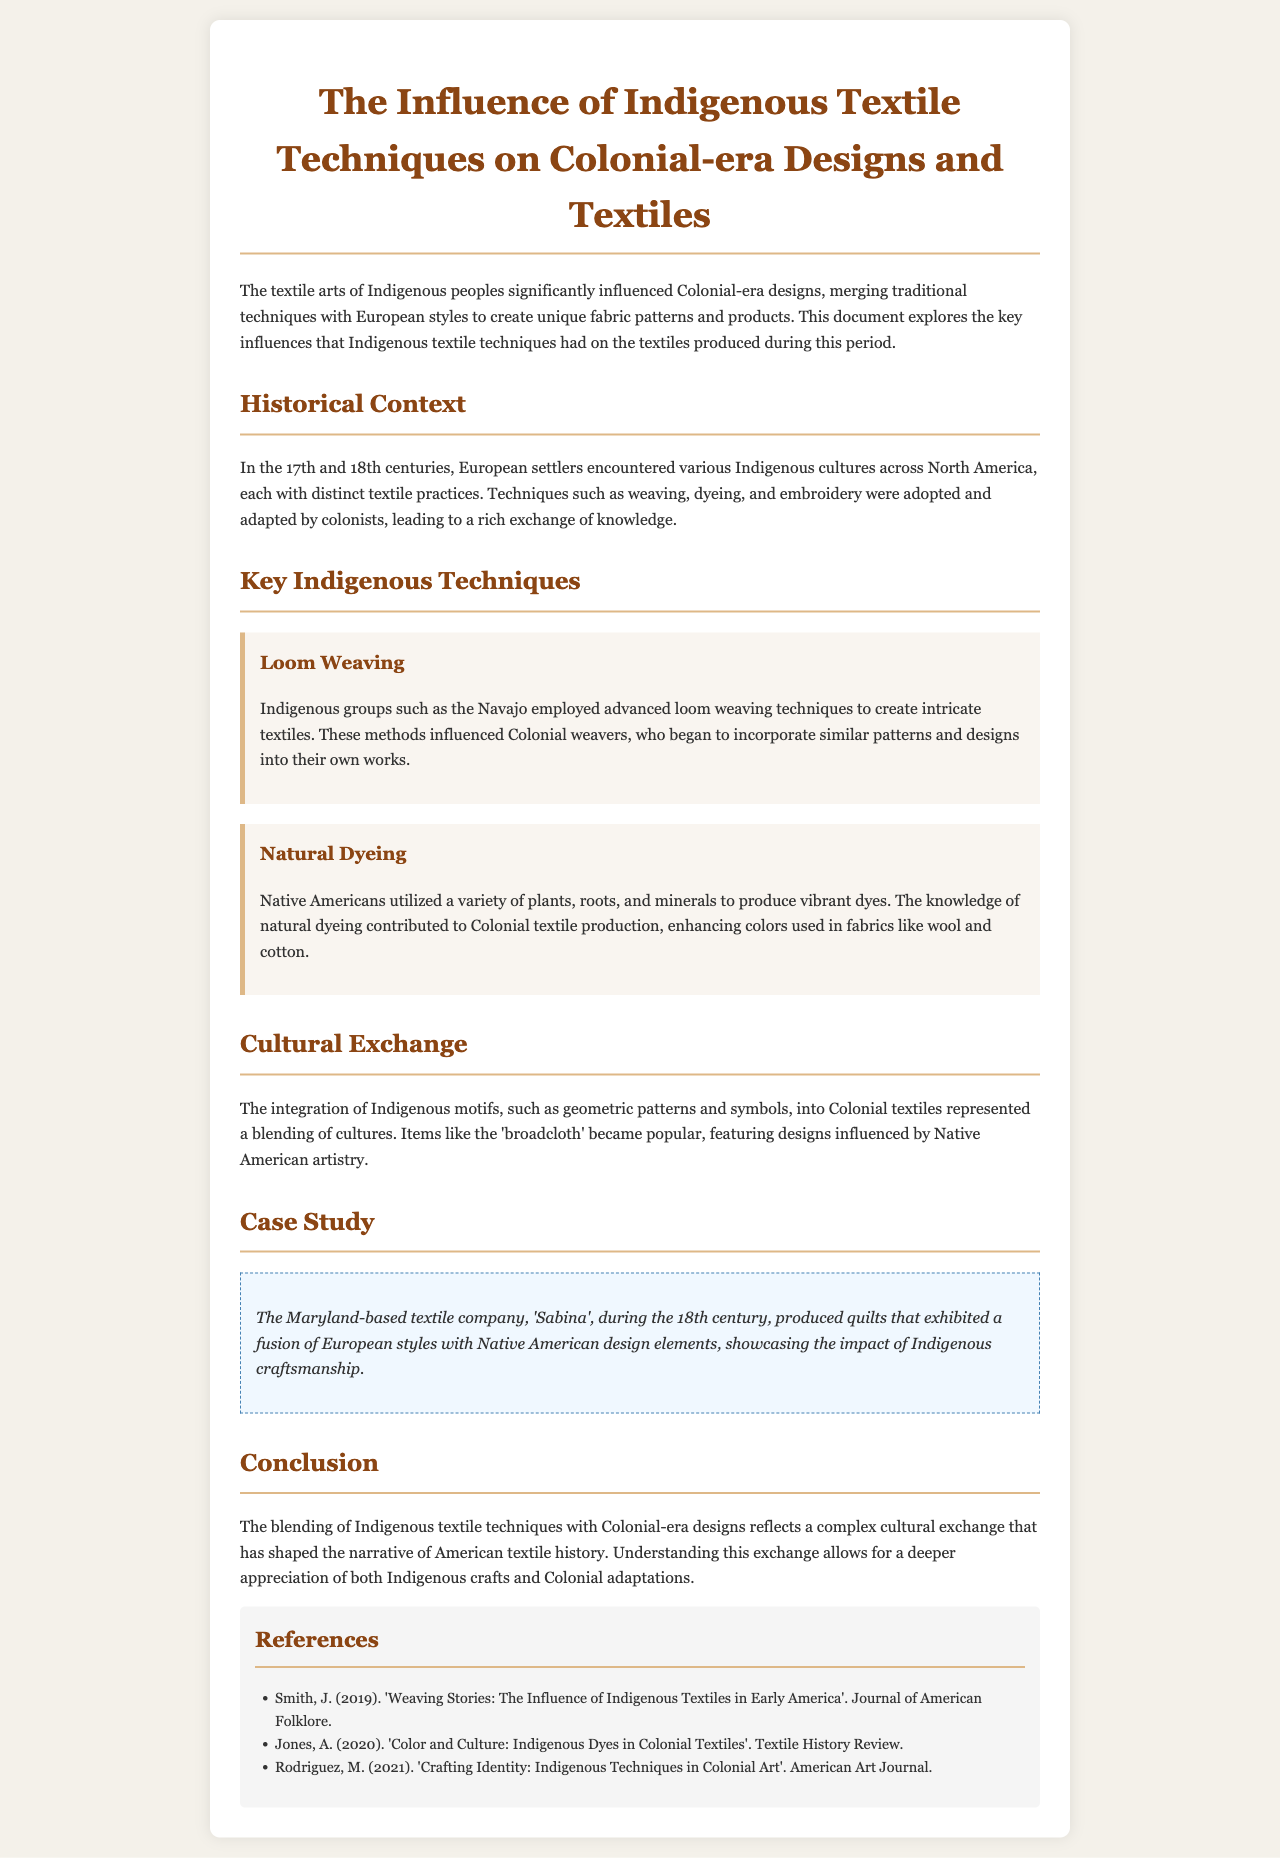What is the title of the document? The title is found at the top of the report, summarizing its main focus.
Answer: The Influence of Indigenous Textile Techniques on Colonial-era Designs and Textiles Which Indigenous group is mentioned for advanced loom weaving techniques? The document explicitly states which Indigenous group employed these techniques within the section discussing key techniques.
Answer: Navajo What century did the Maryland-based textile company 'Sabina' operate in? The case study section specifies the time period during which the company produced its textiles.
Answer: 18th century What type of dyeing did Native Americans use that influenced Colonial textile production? The document identifies the type of dyeing as it relates to vibrant colors in textiles.
Answer: Natural dyeing What did the integration of Indigenous motifs into Colonial textiles represent? The document summarizes the cultural implications of this integration in the cultural exchange section.
Answer: A blending of cultures How did Indigenous techniques influence Colonial weavers? The document mentions the specific techniques and their impact on colonists' practices.
Answer: Incorporate similar patterns and designs What was a popular item featuring designs influenced by Native American artistry? The document refers to a specific product to illustrate the integration of Indigenous designs.
Answer: Broadcloth What are the colors used in fabrics enhanced by Indigenous dyeing methods? The document describes the result of Indigenous dyeing methods applied to specific types of textiles.
Answer: Vibrant colors 